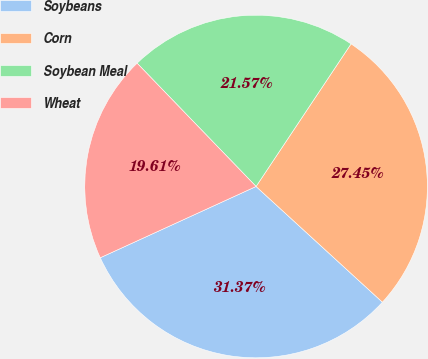<chart> <loc_0><loc_0><loc_500><loc_500><pie_chart><fcel>Soybeans<fcel>Corn<fcel>Soybean Meal<fcel>Wheat<nl><fcel>31.37%<fcel>27.45%<fcel>21.57%<fcel>19.61%<nl></chart> 